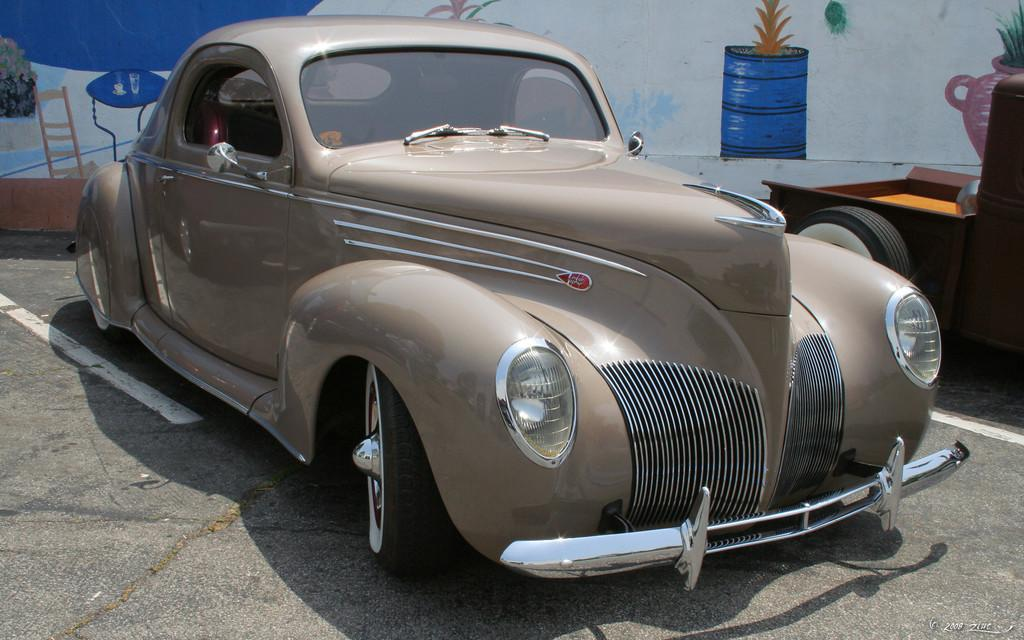What is the main subject of the image? The main subject of the image is a car on the road. Can you describe the background of the image? In the background of the image, there is a wall with a painting on it. What advice does the brother give to the car in the image? There is no brother present in the image, and therefore no advice can be given to the car. 